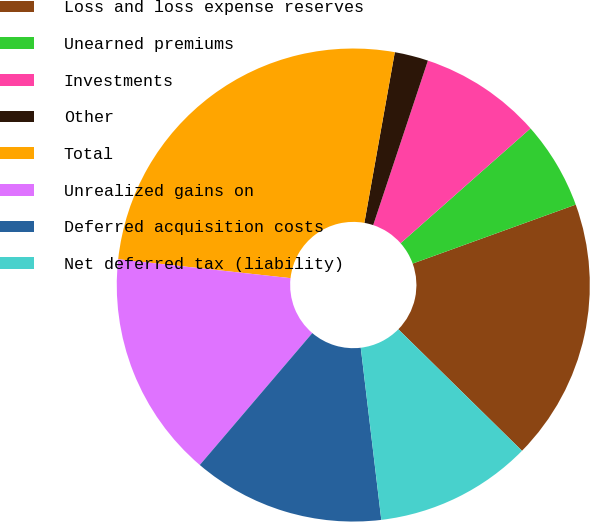Convert chart to OTSL. <chart><loc_0><loc_0><loc_500><loc_500><pie_chart><fcel>Loss and loss expense reserves<fcel>Unearned premiums<fcel>Investments<fcel>Other<fcel>Total<fcel>Unrealized gains on<fcel>Deferred acquisition costs<fcel>Net deferred tax (liability)<nl><fcel>17.88%<fcel>6.0%<fcel>8.37%<fcel>2.3%<fcel>26.07%<fcel>15.5%<fcel>13.13%<fcel>10.75%<nl></chart> 